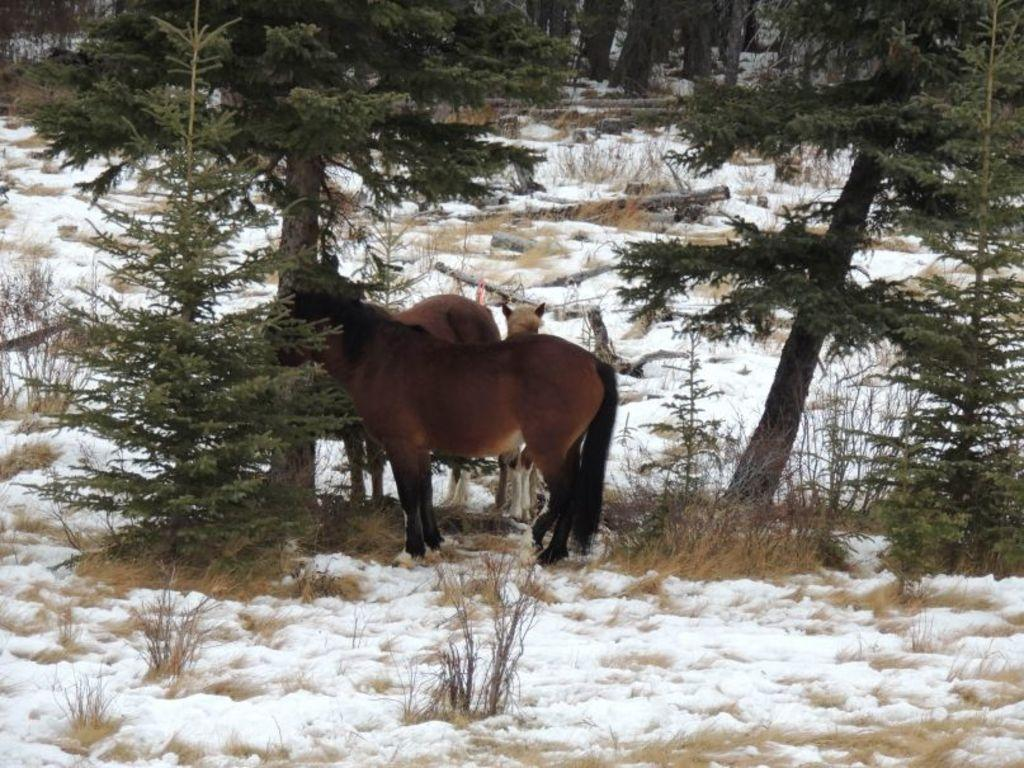What animals are present in the image? There are horses in the image. What color are the horses? The horses are brown in color. What type of terrain is visible in the image? There is snow at the bottom of the image. What other natural elements can be seen in the image? There are trees in the image. Who is the creator of the snow in the image? The image does not provide information about the creator of the snow; it is a natural occurrence. 